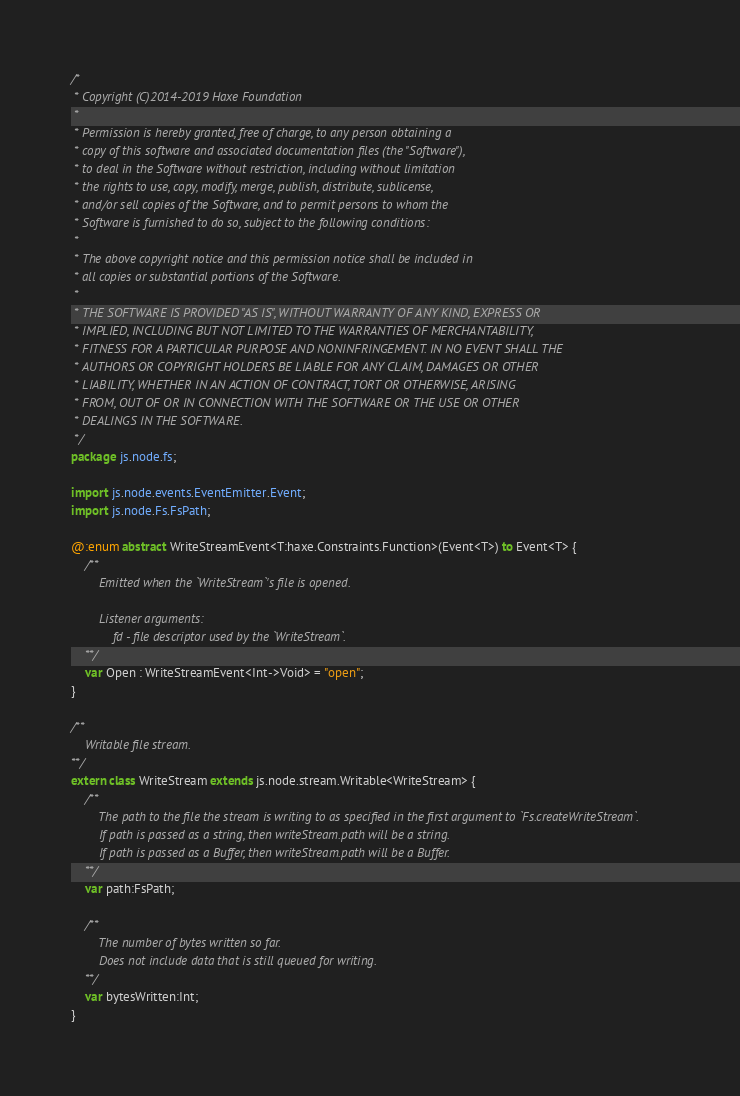Convert code to text. <code><loc_0><loc_0><loc_500><loc_500><_Haxe_>/*
 * Copyright (C)2014-2019 Haxe Foundation
 *
 * Permission is hereby granted, free of charge, to any person obtaining a
 * copy of this software and associated documentation files (the "Software"),
 * to deal in the Software without restriction, including without limitation
 * the rights to use, copy, modify, merge, publish, distribute, sublicense,
 * and/or sell copies of the Software, and to permit persons to whom the
 * Software is furnished to do so, subject to the following conditions:
 *
 * The above copyright notice and this permission notice shall be included in
 * all copies or substantial portions of the Software.
 *
 * THE SOFTWARE IS PROVIDED "AS IS", WITHOUT WARRANTY OF ANY KIND, EXPRESS OR
 * IMPLIED, INCLUDING BUT NOT LIMITED TO THE WARRANTIES OF MERCHANTABILITY,
 * FITNESS FOR A PARTICULAR PURPOSE AND NONINFRINGEMENT. IN NO EVENT SHALL THE
 * AUTHORS OR COPYRIGHT HOLDERS BE LIABLE FOR ANY CLAIM, DAMAGES OR OTHER
 * LIABILITY, WHETHER IN AN ACTION OF CONTRACT, TORT OR OTHERWISE, ARISING
 * FROM, OUT OF OR IN CONNECTION WITH THE SOFTWARE OR THE USE OR OTHER
 * DEALINGS IN THE SOFTWARE.
 */
package js.node.fs;

import js.node.events.EventEmitter.Event;
import js.node.Fs.FsPath;

@:enum abstract WriteStreamEvent<T:haxe.Constraints.Function>(Event<T>) to Event<T> {
	/**
		Emitted when the `WriteStream`'s file is opened.

		Listener arguments:
			fd - file descriptor used by the `WriteStream`.
	**/
	var Open : WriteStreamEvent<Int->Void> = "open";
}

/**
	Writable file stream.
**/
extern class WriteStream extends js.node.stream.Writable<WriteStream> {
	/**
		The path to the file the stream is writing to as specified in the first argument to `Fs.createWriteStream`.
		If path is passed as a string, then writeStream.path will be a string.
		If path is passed as a Buffer, then writeStream.path will be a Buffer.
	**/
	var path:FsPath;

	/**
		The number of bytes written so far.
		Does not include data that is still queued for writing.
	**/
	var bytesWritten:Int;
}
</code> 